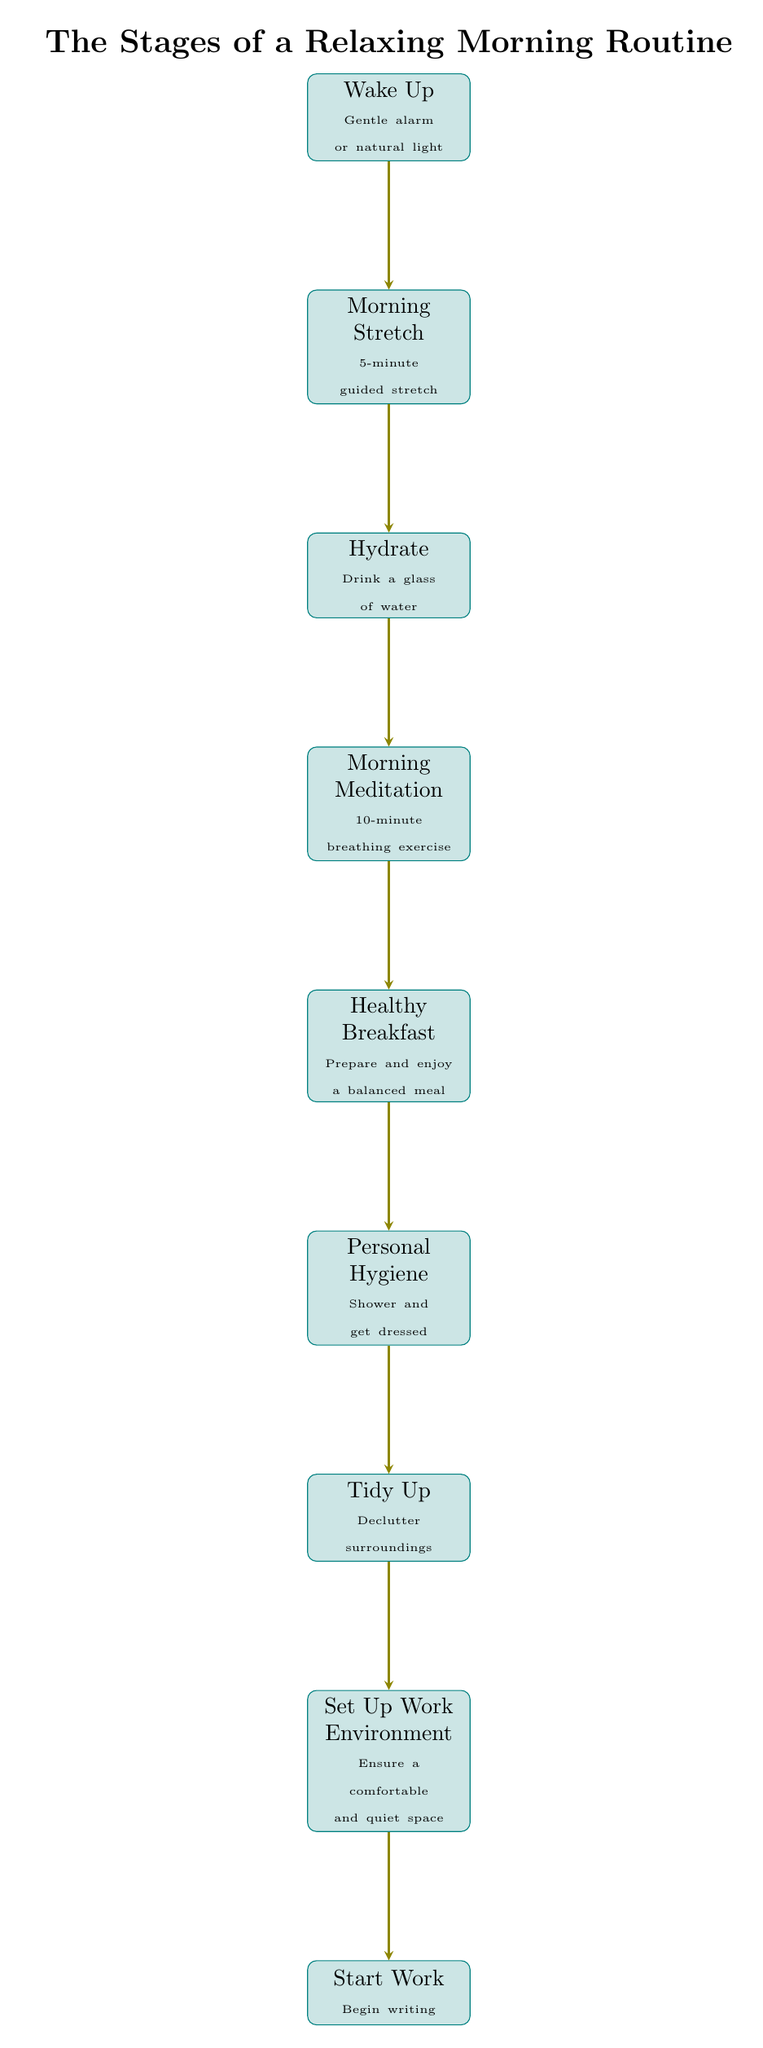What is the first step in the morning routine? The first node in the flowchart represents the initial action of the routine, which is "Wake Up."
Answer: Wake Up How many steps are in the routine? By counting each block in the diagram from the beginning to the end, there are 8 steps in the morning routine.
Answer: 8 What activity follows morning meditation? The flow of arrows indicates that after "Morning Meditation," the next activity is "Healthy Breakfast."
Answer: Healthy Breakfast What is the last step before starting work? The flowchart shows that "Set Up Work Environment" is the action immediately preceding "Start Work."
Answer: Set Up Work Environment Which step involves personal care? The diagram highlights "Personal Hygiene" as the block focusing on personal care activities.
Answer: Personal Hygiene How does the step "Tidy Up" relate to "Set Up Work Environment"? The arrows indicate a direct relationship where "Tidy Up" leads to "Set Up Work Environment," suggesting that decluttering is essential before establishing a work area.
Answer: Directly sequential What activity is recommended to hydrate? The relevant block mentions the specific action to "Drink a glass of water" for hydration.
Answer: Drink a glass of water What time duration is suggested for morning meditation? The diagram specifies a 10-minute duration for the "Morning Meditation" step.
Answer: 10-minute What is the purpose of the "Morning Stretch"? This step's description provides a brief explanation, stating that it is a "5-minute guided stretch," indicating its purpose is to physically prepare the body for the day.
Answer: To physically prepare the body 